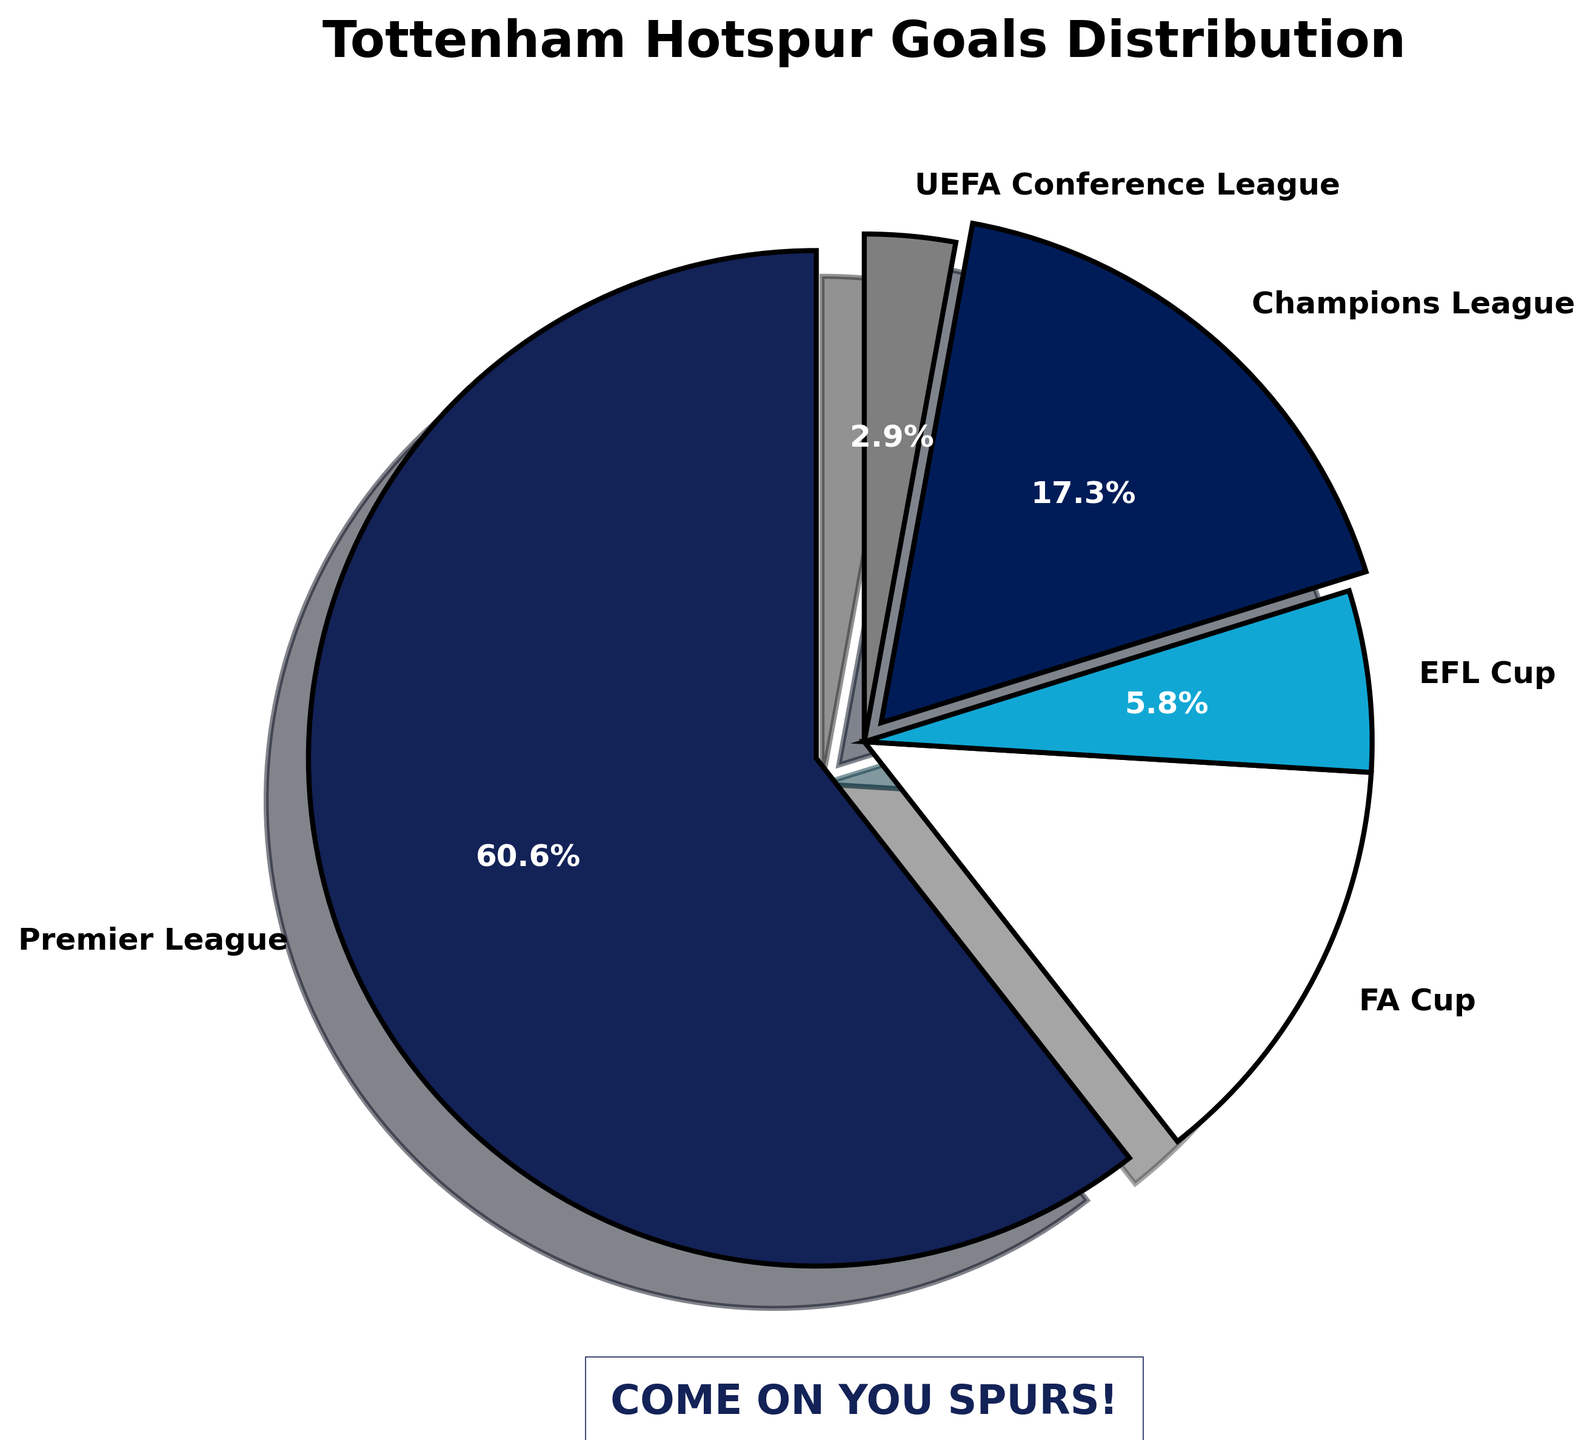what percentage of goals were scored in the Premier League? The pie chart shows that the slice labeled Premier League indicates 63 goals. The percentage is marked on the pie chart as a direct label within this slice.
Answer: 63% How many goals were scored in the UEFA Conference League? The pie chart has a slice labeled "UEFA Conference League" showing the corresponding number of goals within the chart.
Answer: 3 goals Which competition had the second-largest number of goals? By visually assessing the pie chart, the Premier League has the most goals, and the next largest slice is the Champions League.
Answer: Champions League Are there more goals scored in domestic cups (FA Cup and EFL Cup) combined than in the Champions League? Summing up the goals from the FA Cup (14) and EFL Cup (6), we get 14 + 6 = 20 goals. Comparatively, the Champions League shows 18 goals. 20 is greater than 18.
Answer: Yes By how much does the number of goals scored in the Premier League exceed the goals scored in the Champions League? The Premier League shows 63 goals, and the Champions League shows 18 goals. The difference is 63 - 18.
Answer: 45 goals Which competition's goals have been visually highlighted by an explosion effect in the pie chart? The visual explosion effect is noticeable in the slices labeled Premier League and Champions League, with distances from the pie.
Answer: Premier League and Champions League What fraction of the total goals scored were in the FA Cup? The chart shows the FA Cup with 14 goals. To find the fraction of total goals, sum all the competition goals: 63 (PL)+ 14 (FA) + 6 (EFL) + 18 (Champions) + 3 (UEFA Conference) = 104. The fraction is 14/104.
Answer: 14/104 What visually distinguishes the slice for the Premier League from the others? The Premier League slice is exploded slightly outward, and it is shaded in a dark blue color.
Answer: Exploded and dark blue If UEFA Conference League goals were doubled, would its proportion exceed the EFL Cup goals? If UEFA Conference League goals doubled from 3 to 6, compare it with the EFL Cup's 6 goals. Since they are equal, investigation shows they would occupy similar proportions but not exceed.
Answer: They would be equal What message is displayed at the bottom of the pie chart? The annotation at the bottom of the pie chart reads "COME ON YOU SPURS!".
Answer: COME ON YOU SPURS! 